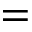Convert formula to latex. <formula><loc_0><loc_0><loc_500><loc_500>=</formula> 